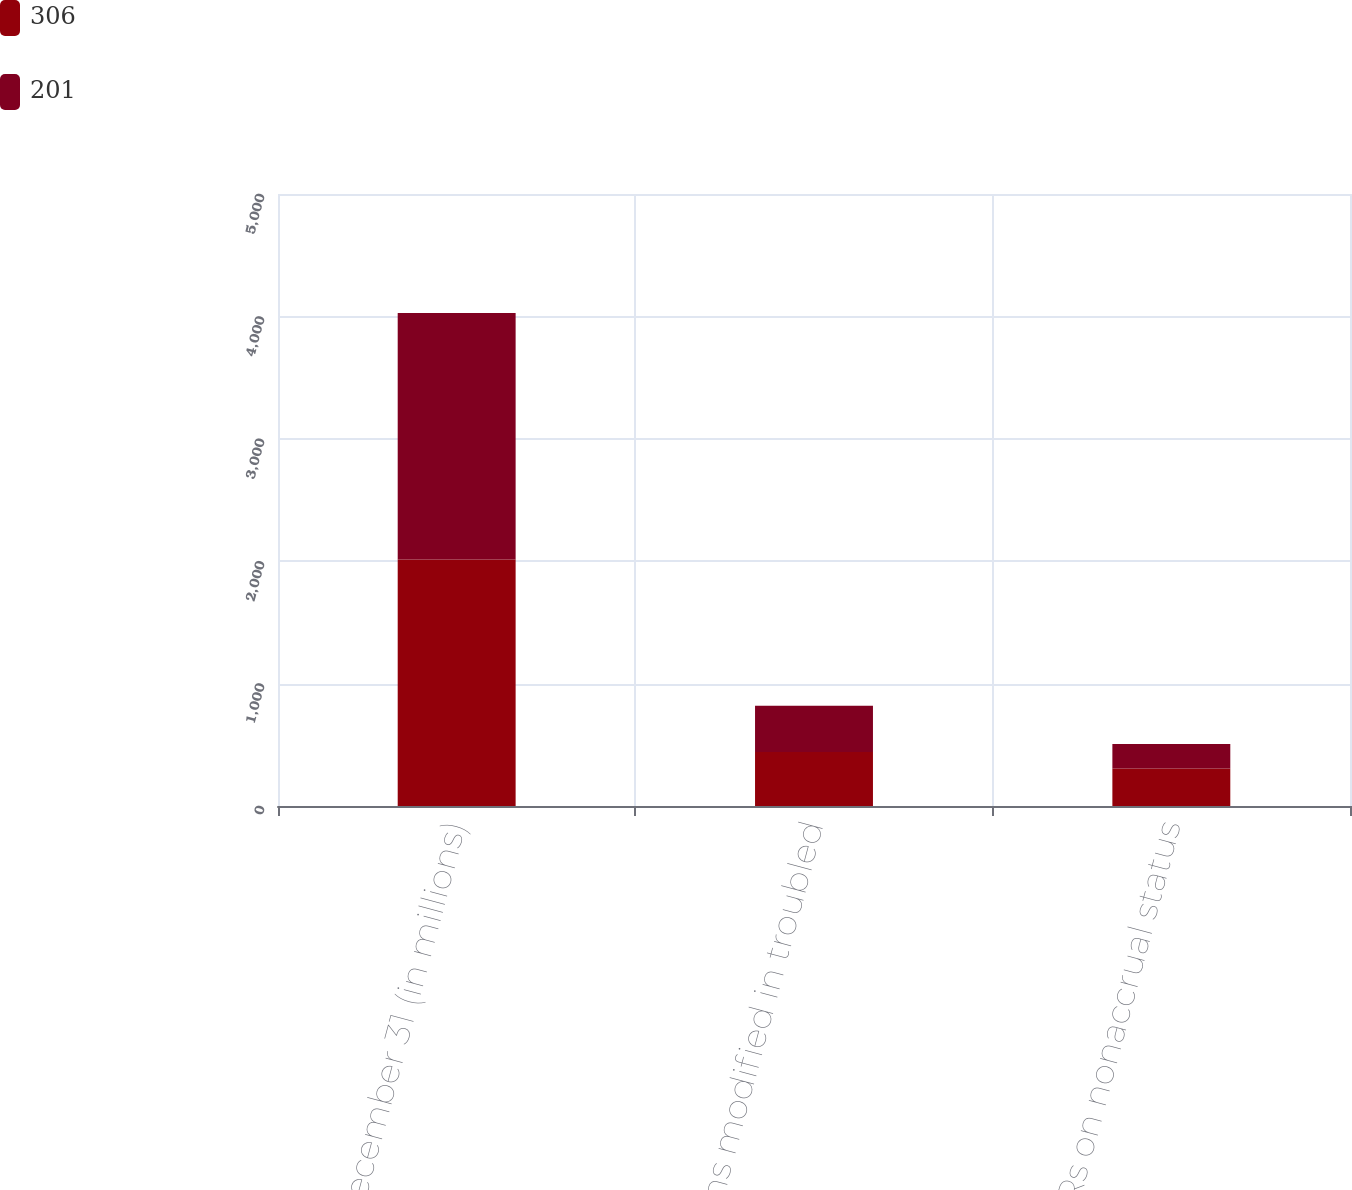Convert chart. <chart><loc_0><loc_0><loc_500><loc_500><stacked_bar_chart><ecel><fcel>December 31 (in millions)<fcel>Loans modified in troubled<fcel>TDRs on nonaccrual status<nl><fcel>306<fcel>2014<fcel>442<fcel>306<nl><fcel>201<fcel>2013<fcel>378<fcel>201<nl></chart> 